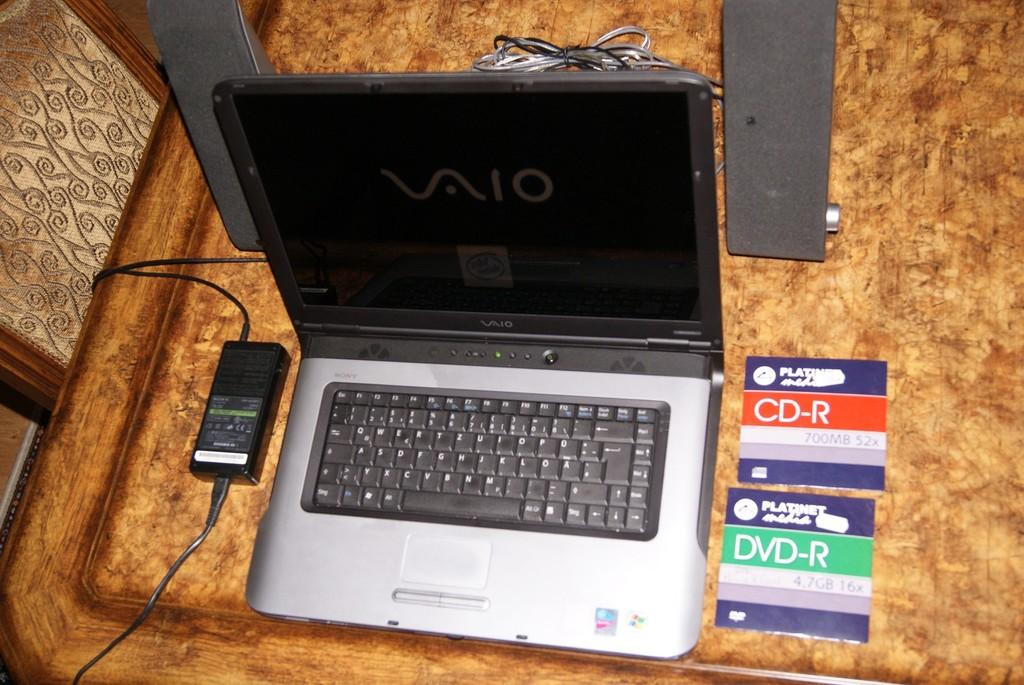<image>
Summarize the visual content of the image. A Vaio laptop sits next to two a CD-R card and a DVD-R card. 